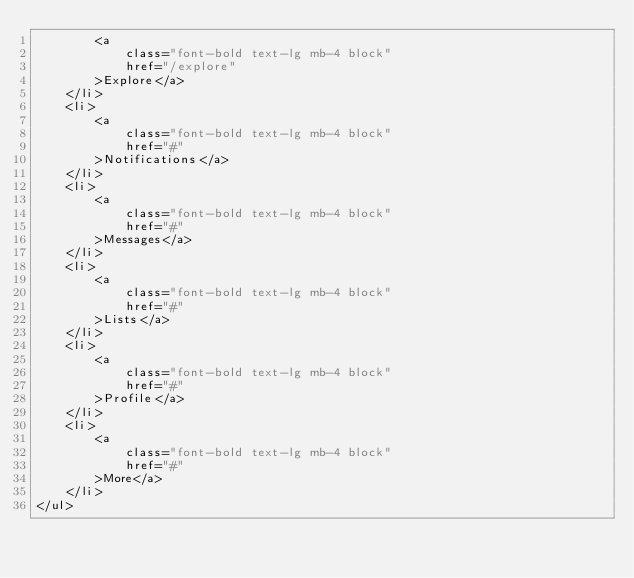<code> <loc_0><loc_0><loc_500><loc_500><_PHP_>        <a
            class="font-bold text-lg mb-4 block"
            href="/explore"
        >Explore</a>
    </li>
    <li>
        <a
            class="font-bold text-lg mb-4 block"
            href="#"
        >Notifications</a>
    </li>
    <li>
        <a
            class="font-bold text-lg mb-4 block"
            href="#"
        >Messages</a>
    </li>
    <li>
        <a
            class="font-bold text-lg mb-4 block"
            href="#"
        >Lists</a>
    </li>
    <li>
        <a
            class="font-bold text-lg mb-4 block"
            href="#"
        >Profile</a>
    </li>
    <li>
        <a
            class="font-bold text-lg mb-4 block"
            href="#"
        >More</a>
    </li>
</ul>
</code> 